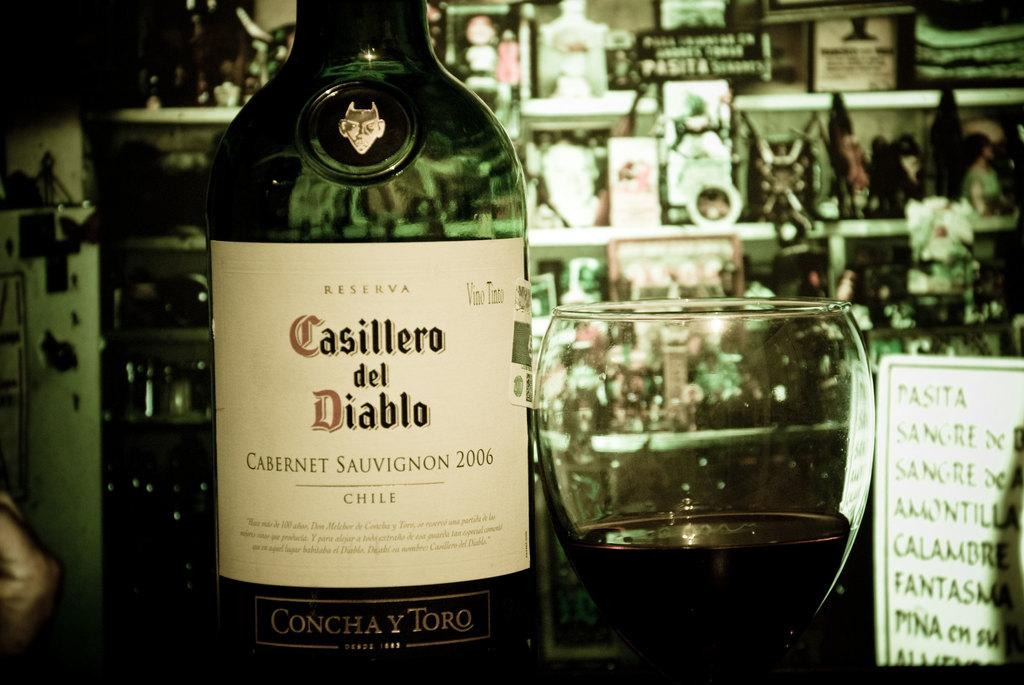<image>
Summarize the visual content of the image. A bottle of Casillero del Diablo sits next to a glass. 